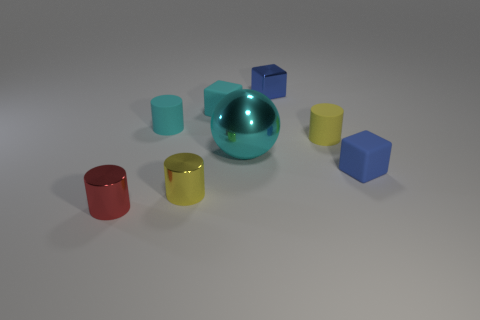What color is the matte cylinder that is right of the big cyan object? The matte cylinder situated to the right of the large cyan object is yellow, exhibiting a soft texture indicative of a matte finish. 